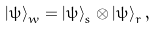Convert formula to latex. <formula><loc_0><loc_0><loc_500><loc_500>\left | \psi \right \rangle _ { w } = \left | \psi \right \rangle _ { s } \otimes \left | \psi \right \rangle _ { r } ,</formula> 